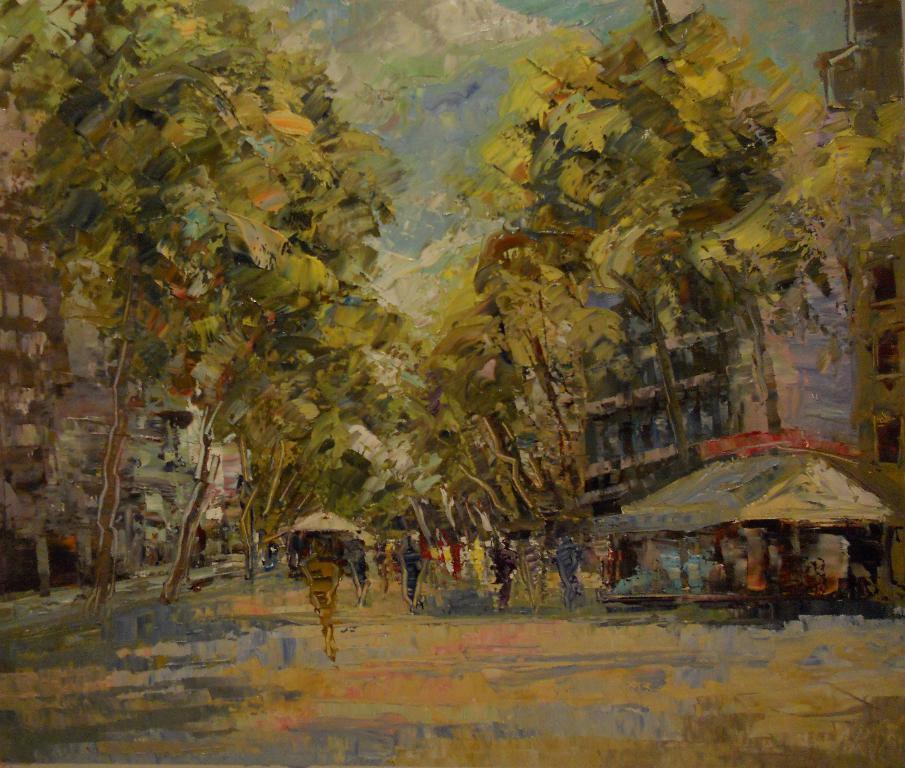Please provide a concise description of this image. In this image we can see a painting. In the painting there are sky with clouds, trees, buildings, shed and persons on the road. 